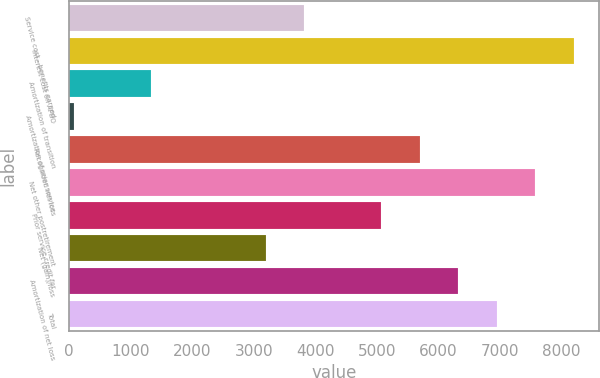Convert chart. <chart><loc_0><loc_0><loc_500><loc_500><bar_chart><fcel>Service cost - benefits earned<fcel>Interest cost on APBO<fcel>Amortization of transition<fcel>Amortization of prior service<fcel>Recognized net loss<fcel>Net other postretirement<fcel>Prior service credit for<fcel>Net (gain)/loss<fcel>Amortization of net loss<fcel>Total<nl><fcel>3826<fcel>8201<fcel>1326<fcel>76<fcel>5701<fcel>7576<fcel>5076<fcel>3201<fcel>6326<fcel>6951<nl></chart> 